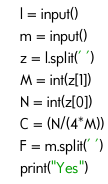<code> <loc_0><loc_0><loc_500><loc_500><_Python_>l = input()
m = input()
z = l.split(' ')
M = int(z[1])
N = int(z[0])
C = (N/(4*M))
F = m.split(' ')
print("Yes")
</code> 